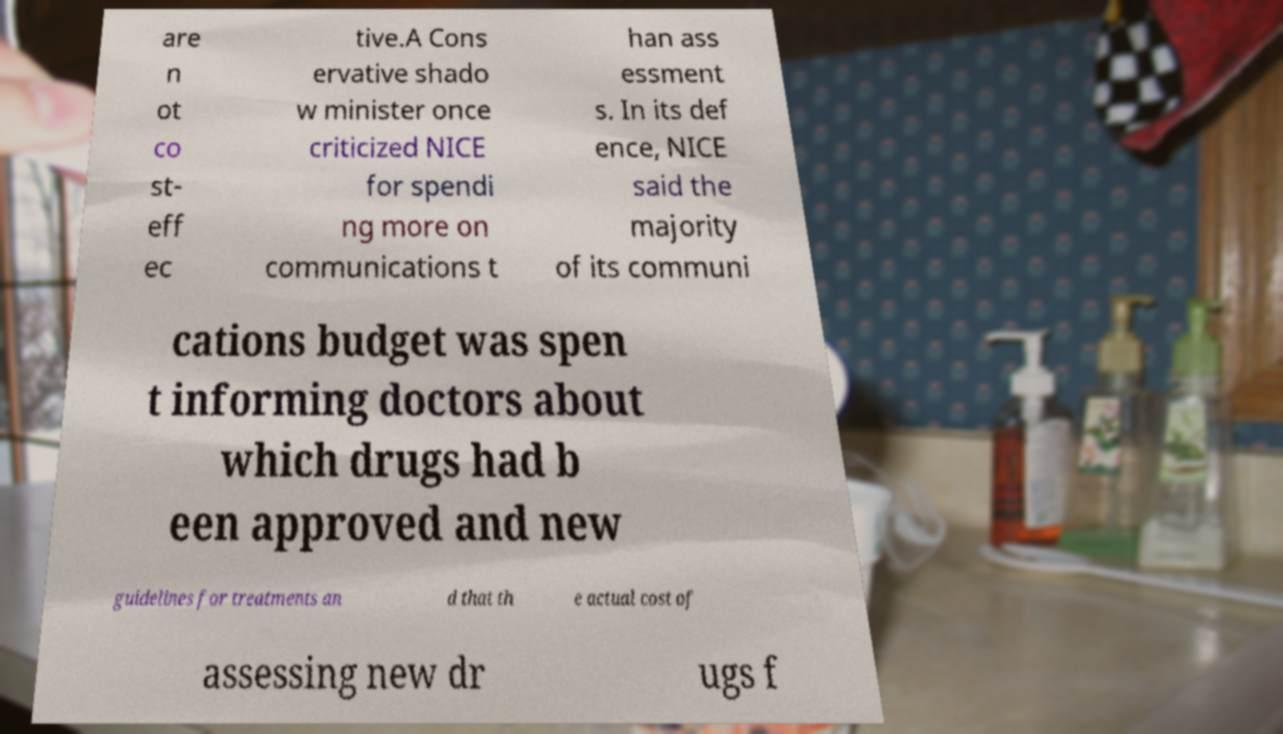Please identify and transcribe the text found in this image. are n ot co st- eff ec tive.A Cons ervative shado w minister once criticized NICE for spendi ng more on communications t han ass essment s. In its def ence, NICE said the majority of its communi cations budget was spen t informing doctors about which drugs had b een approved and new guidelines for treatments an d that th e actual cost of assessing new dr ugs f 